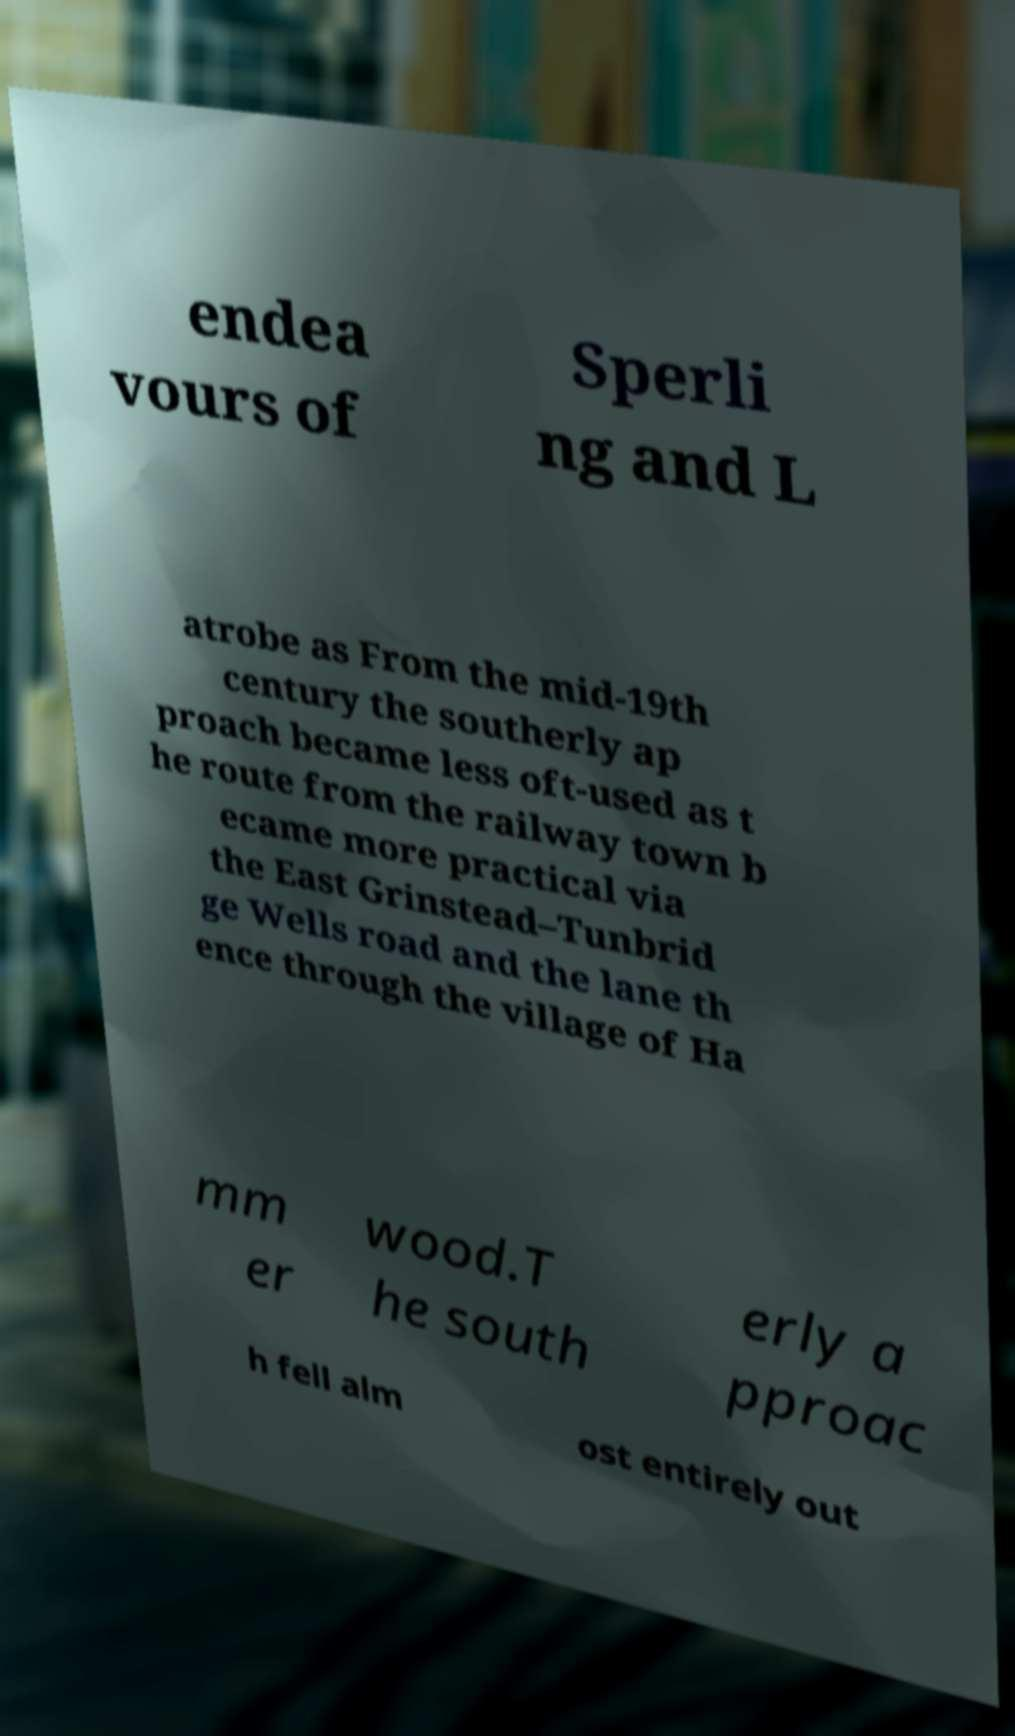What messages or text are displayed in this image? I need them in a readable, typed format. endea vours of Sperli ng and L atrobe as From the mid-19th century the southerly ap proach became less oft-used as t he route from the railway town b ecame more practical via the East Grinstead–Tunbrid ge Wells road and the lane th ence through the village of Ha mm er wood.T he south erly a pproac h fell alm ost entirely out 